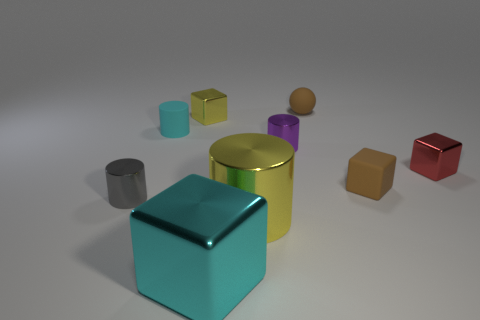Subtract all yellow cylinders. Subtract all gray balls. How many cylinders are left? 3 Subtract all spheres. How many objects are left? 8 Subtract 0 brown cylinders. How many objects are left? 9 Subtract all tiny red cubes. Subtract all cyan cylinders. How many objects are left? 7 Add 4 tiny spheres. How many tiny spheres are left? 5 Add 7 big yellow rubber balls. How many big yellow rubber balls exist? 7 